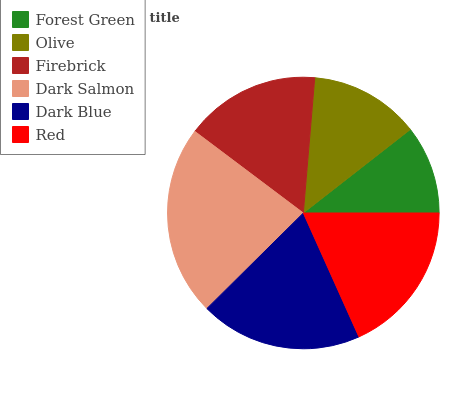Is Forest Green the minimum?
Answer yes or no. Yes. Is Dark Salmon the maximum?
Answer yes or no. Yes. Is Olive the minimum?
Answer yes or no. No. Is Olive the maximum?
Answer yes or no. No. Is Olive greater than Forest Green?
Answer yes or no. Yes. Is Forest Green less than Olive?
Answer yes or no. Yes. Is Forest Green greater than Olive?
Answer yes or no. No. Is Olive less than Forest Green?
Answer yes or no. No. Is Red the high median?
Answer yes or no. Yes. Is Firebrick the low median?
Answer yes or no. Yes. Is Dark Salmon the high median?
Answer yes or no. No. Is Dark Salmon the low median?
Answer yes or no. No. 